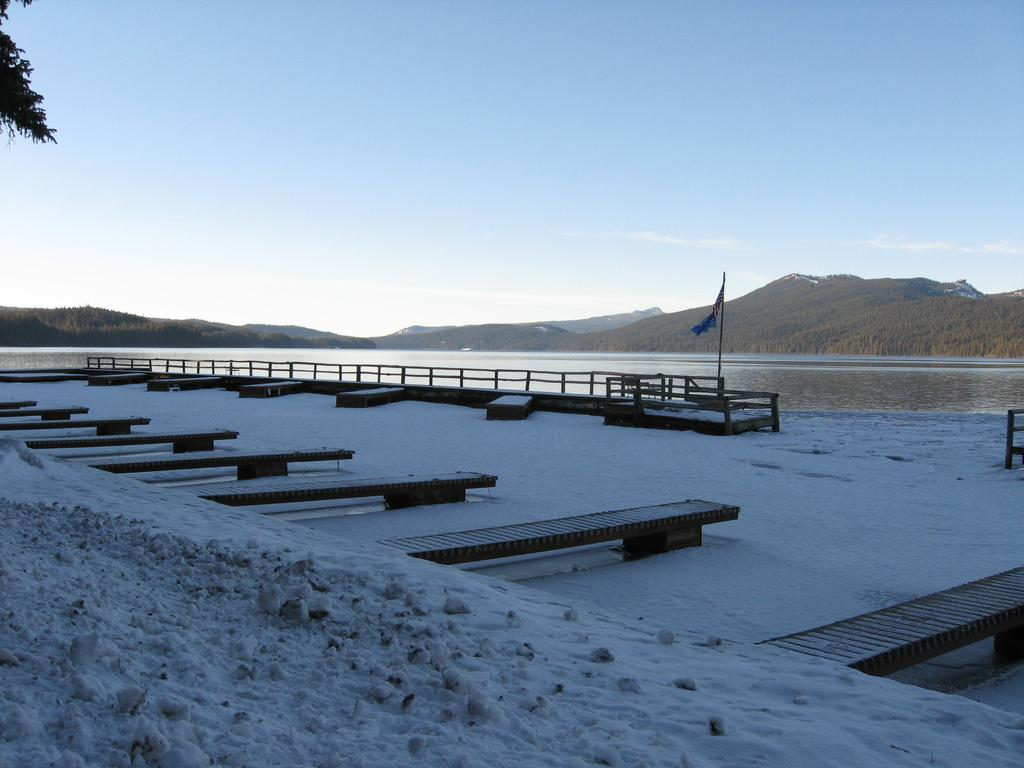What type of seating can be seen in the image? There are many benches in the image. What is covering the ground in the image? The ground is covered with snow. What can be seen in the background of the image? There is a railing, a flag, water, hills, and the sky visible in the background of the image. Where is the pig carrying the tray in the image? There is no pig or tray present in the image. 